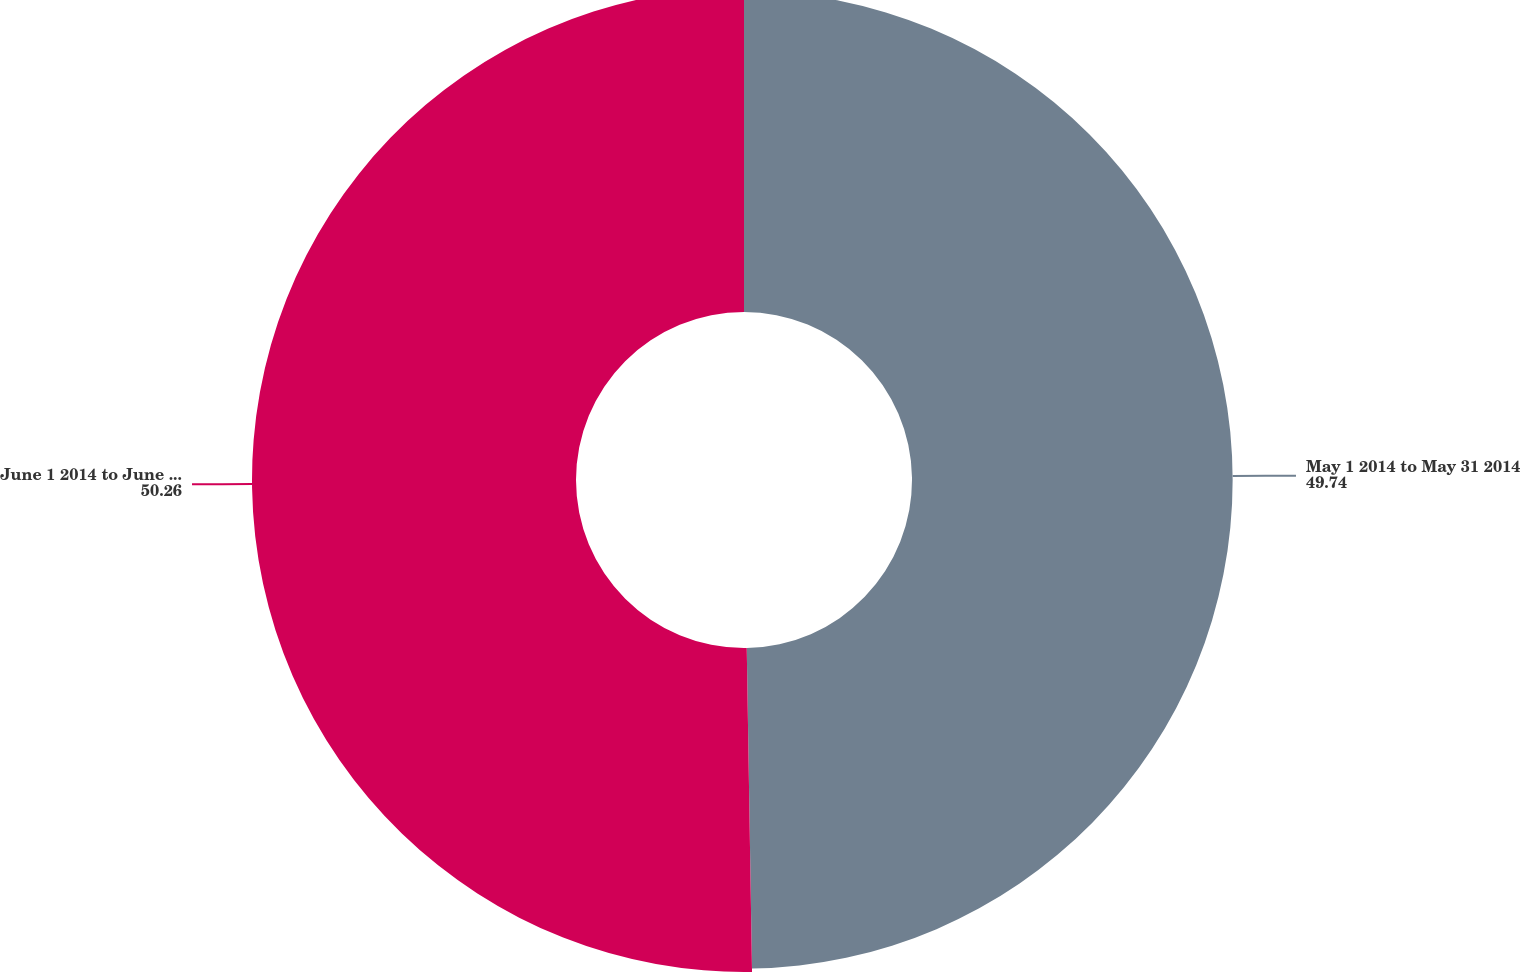<chart> <loc_0><loc_0><loc_500><loc_500><pie_chart><fcel>May 1 2014 to May 31 2014<fcel>June 1 2014 to June 30 2014<nl><fcel>49.74%<fcel>50.26%<nl></chart> 